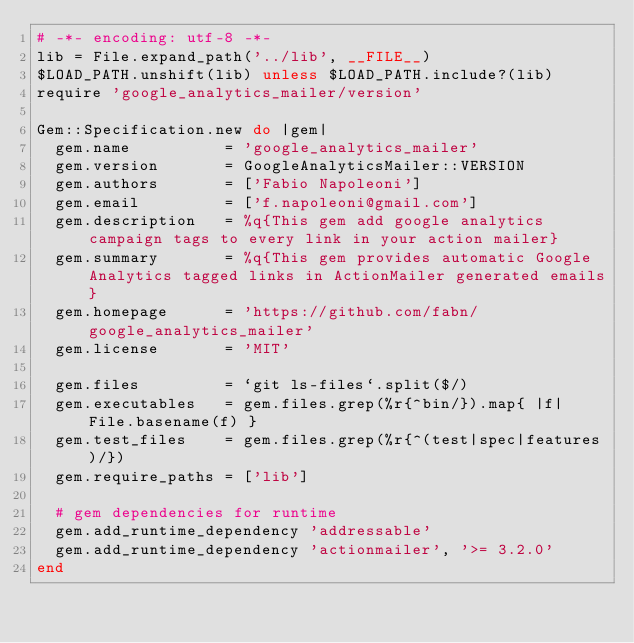Convert code to text. <code><loc_0><loc_0><loc_500><loc_500><_Ruby_># -*- encoding: utf-8 -*-
lib = File.expand_path('../lib', __FILE__)
$LOAD_PATH.unshift(lib) unless $LOAD_PATH.include?(lib)
require 'google_analytics_mailer/version'

Gem::Specification.new do |gem|
  gem.name          = 'google_analytics_mailer'
  gem.version       = GoogleAnalyticsMailer::VERSION
  gem.authors       = ['Fabio Napoleoni']
  gem.email         = ['f.napoleoni@gmail.com']
  gem.description   = %q{This gem add google analytics campaign tags to every link in your action mailer}
  gem.summary       = %q{This gem provides automatic Google Analytics tagged links in ActionMailer generated emails}
  gem.homepage      = 'https://github.com/fabn/google_analytics_mailer'
  gem.license       = 'MIT'

  gem.files         = `git ls-files`.split($/)
  gem.executables   = gem.files.grep(%r{^bin/}).map{ |f| File.basename(f) }
  gem.test_files    = gem.files.grep(%r{^(test|spec|features)/})
  gem.require_paths = ['lib']

  # gem dependencies for runtime
  gem.add_runtime_dependency 'addressable'
  gem.add_runtime_dependency 'actionmailer', '>= 3.2.0'
end
</code> 